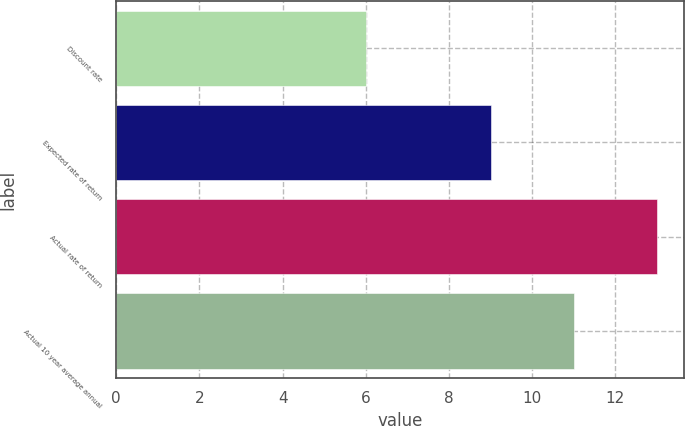Convert chart. <chart><loc_0><loc_0><loc_500><loc_500><bar_chart><fcel>Discount rate<fcel>Expected rate of return<fcel>Actual rate of return<fcel>Actual 10 year average annual<nl><fcel>6<fcel>9<fcel>13<fcel>11<nl></chart> 